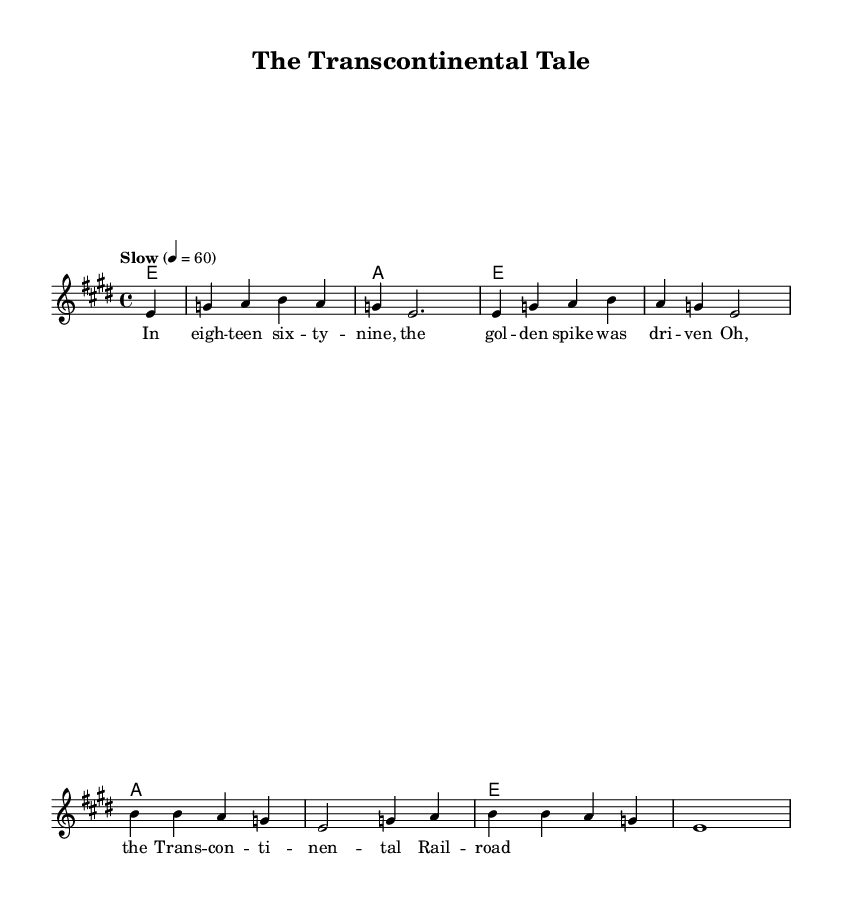What is the key signature of this music? The key signature is E major, which has four sharps: F#, C#, G#, and D#. This can be determined by looking at the signature at the beginning of the sheet music.
Answer: E major What is the time signature of this music? The time signature is 4/4, indicating four beats per measure with a quarter note receiving one beat. This is indicated at the beginning of the sheet music, right after the key signature.
Answer: 4/4 What is the tempo marking of this music? The tempo marking is "Slow" and indicates that the piece should be performed at a speed of 60 beats per minute. This information is stated at the top of the sheet music, under the tempo indication.
Answer: Slow How many measures are in the melody? The melody contains 8 measures, which can be counted by looking at the vertical lines that separate each measure in the staff.
Answer: 8 What type of song structure does this blues piece follow? The song structure follows a simple AAB pattern, which is common in blues music where two lines are repeated and followed by a concluding line. This can be deduced from the structure of the lyrics and their repetition in the sheet music.
Answer: AAB What historical event is referenced in the lyrics? The historical event referenced is the driving of the golden spike for the Transcontinental Railroad in 1869. This can be inferred from the lyrics, which mention the event and its significance to the railroad.
Answer: Transcontinental Railroad 